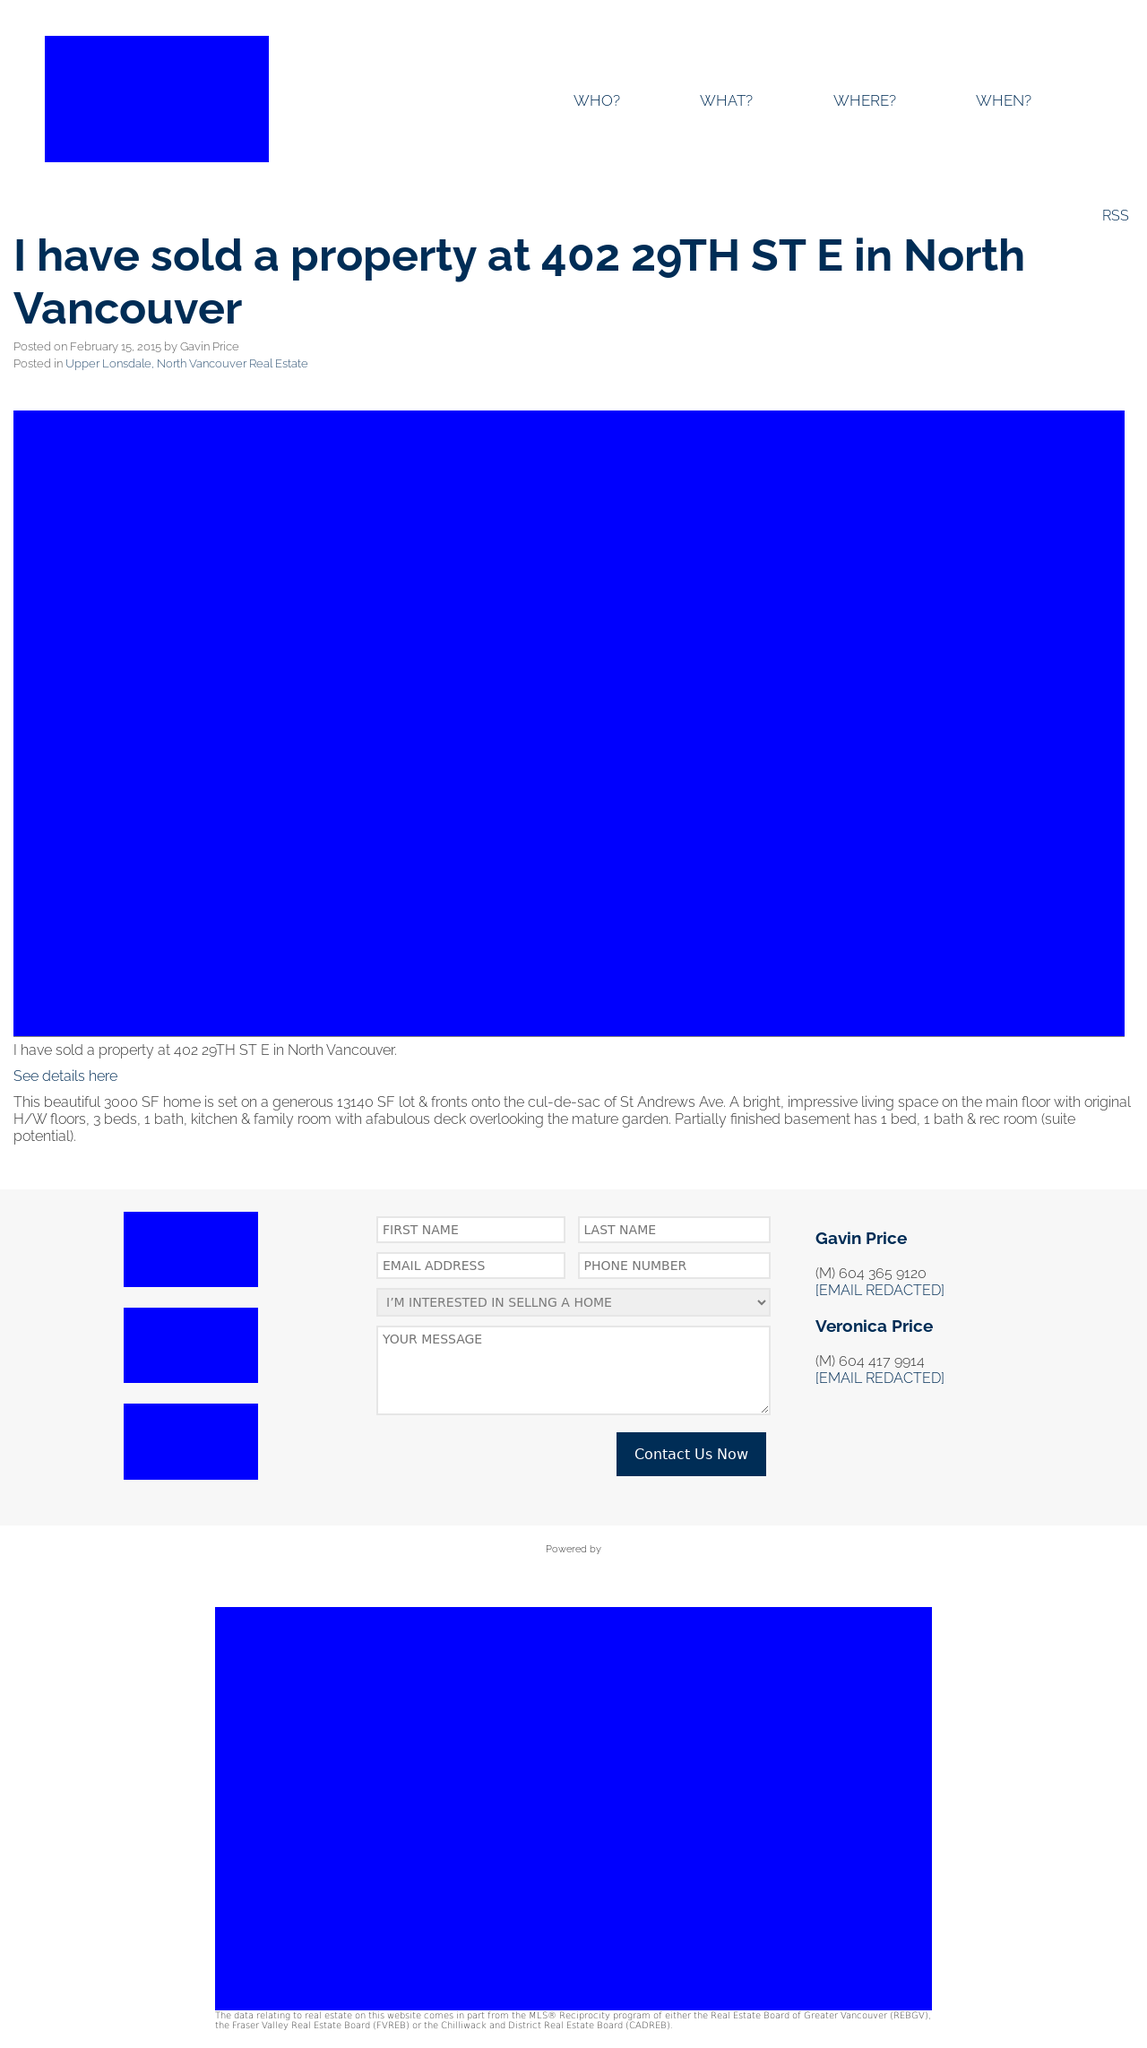What's the procedure for constructing this website from scratch with HTML? To construct a website similar to the one shown from scratch using HTML, start by creating the basic structure with HTML tags such as <!DOCTYPE html>, <html>, <head>, and <body>. Inside <head>, place meta tags for defining the character set, viewport, and title of your web page. Within the <body>, you can use various tags like <header>, <nav> for navigation bars, <section> or <div> for different content sections, and <footer> for the footer area. You will also need to link your CSS for styling, which is crucial to achieve the blue layout and structured format as seen in the image. 